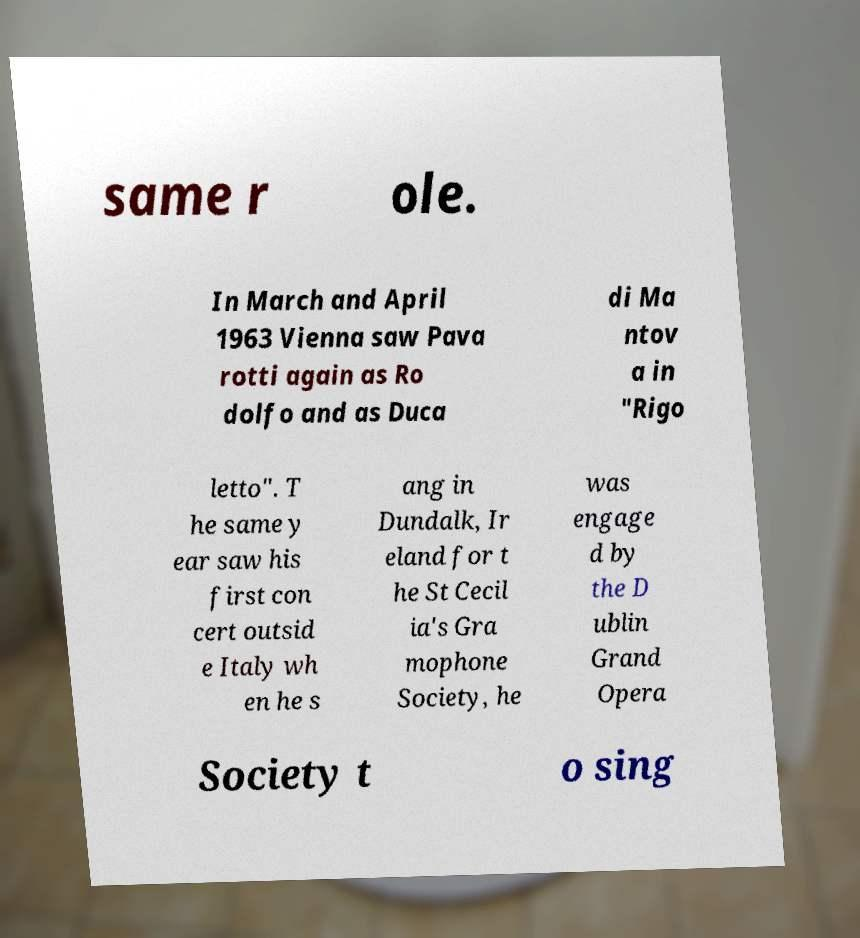Could you assist in decoding the text presented in this image and type it out clearly? same r ole. In March and April 1963 Vienna saw Pava rotti again as Ro dolfo and as Duca di Ma ntov a in "Rigo letto". T he same y ear saw his first con cert outsid e Italy wh en he s ang in Dundalk, Ir eland for t he St Cecil ia's Gra mophone Society, he was engage d by the D ublin Grand Opera Society t o sing 